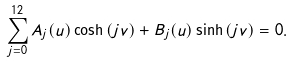Convert formula to latex. <formula><loc_0><loc_0><loc_500><loc_500>\sum _ { j = 0 } ^ { 1 2 } A _ { j } ( u ) \cosh { ( j v ) } + B _ { j } ( u ) \sinh { ( j v ) } = 0 .</formula> 